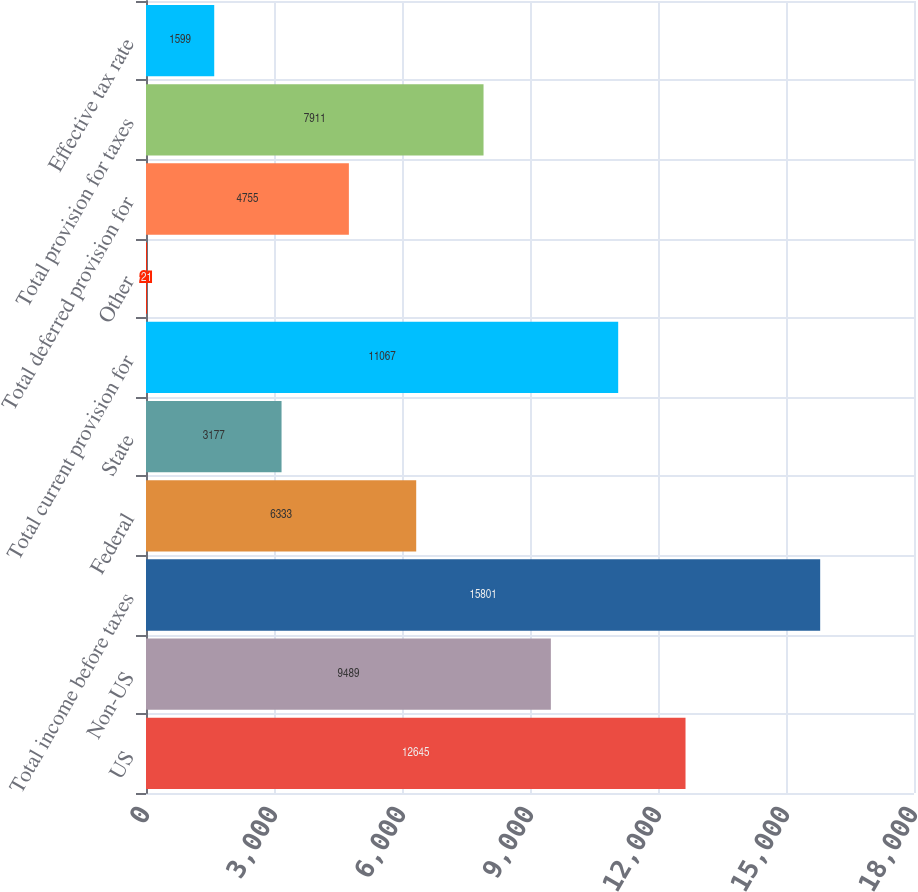Convert chart to OTSL. <chart><loc_0><loc_0><loc_500><loc_500><bar_chart><fcel>US<fcel>Non-US<fcel>Total income before taxes<fcel>Federal<fcel>State<fcel>Total current provision for<fcel>Other<fcel>Total deferred provision for<fcel>Total provision for taxes<fcel>Effective tax rate<nl><fcel>12645<fcel>9489<fcel>15801<fcel>6333<fcel>3177<fcel>11067<fcel>21<fcel>4755<fcel>7911<fcel>1599<nl></chart> 